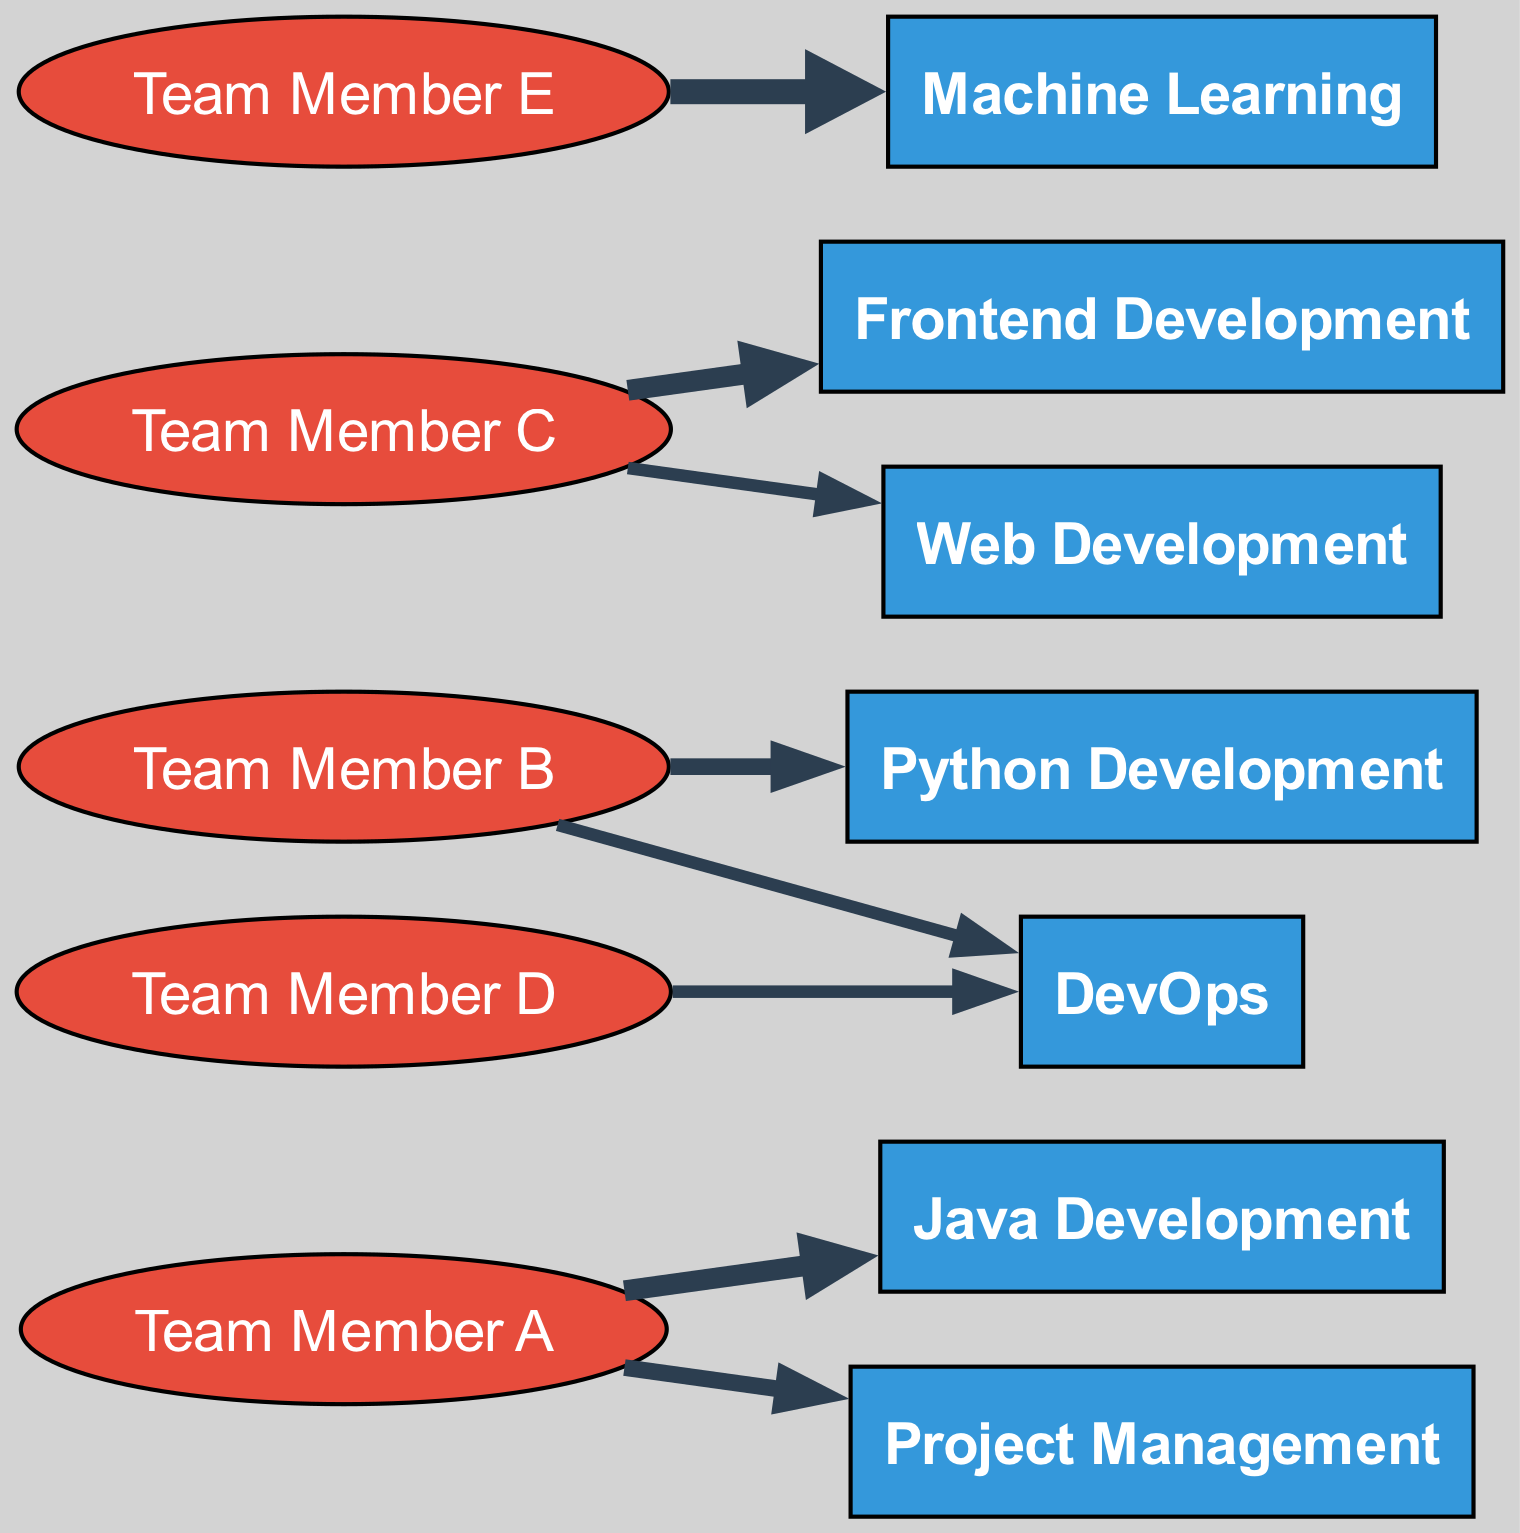What skill has the highest value associated with it? By examining the links connected to the skills, it can be seen that the highest value is associated with "Machine Learning," which has a value of 5.
Answer: Machine Learning How many team members are associated with "DevOps"? Looking at the connections in the diagram, two team members, "Team Member D" and "Team Member B," are linked to "DevOps."
Answer: 2 Which team member has the most skills associated with them? By assessing the number of connections for each team member, "Team Member A" has skills in "Java Development" and "Project Management," totaling 2 skills, while others have fewer connections.
Answer: Team Member A What is the total number of nodes in the diagram? The nodes are made up of 6 skills and 5 team members, hence there is a total of 11 nodes in the diagram.
Answer: 11 How many total connections (links) are there in the diagram? Counting all links, there are 8 connections that represent the flow between team members and their associated skills.
Answer: 8 Which skill is associated with "Team Member C"? "Team Member C" has links to "Frontend Development" and "Web Development," thus associated with these two skills.
Answer: Frontend Development, Web Development What is the value of the connection from "Team Member E" to "Machine Learning"? The value associated with this connection is clearly 5, indicating the strength of the association.
Answer: 5 Which member has the least number of skill connections? Analyzing the connections, "Team Member D" has the least skill connections, linking only to "DevOps" and having a value of 2.
Answer: Team Member D What skill do "Team Member A" and "Team Member B" share in terms of connection? Both "Team Member A" and "Team Member B" are connected to "DevOps," though with different values.
Answer: DevOps 